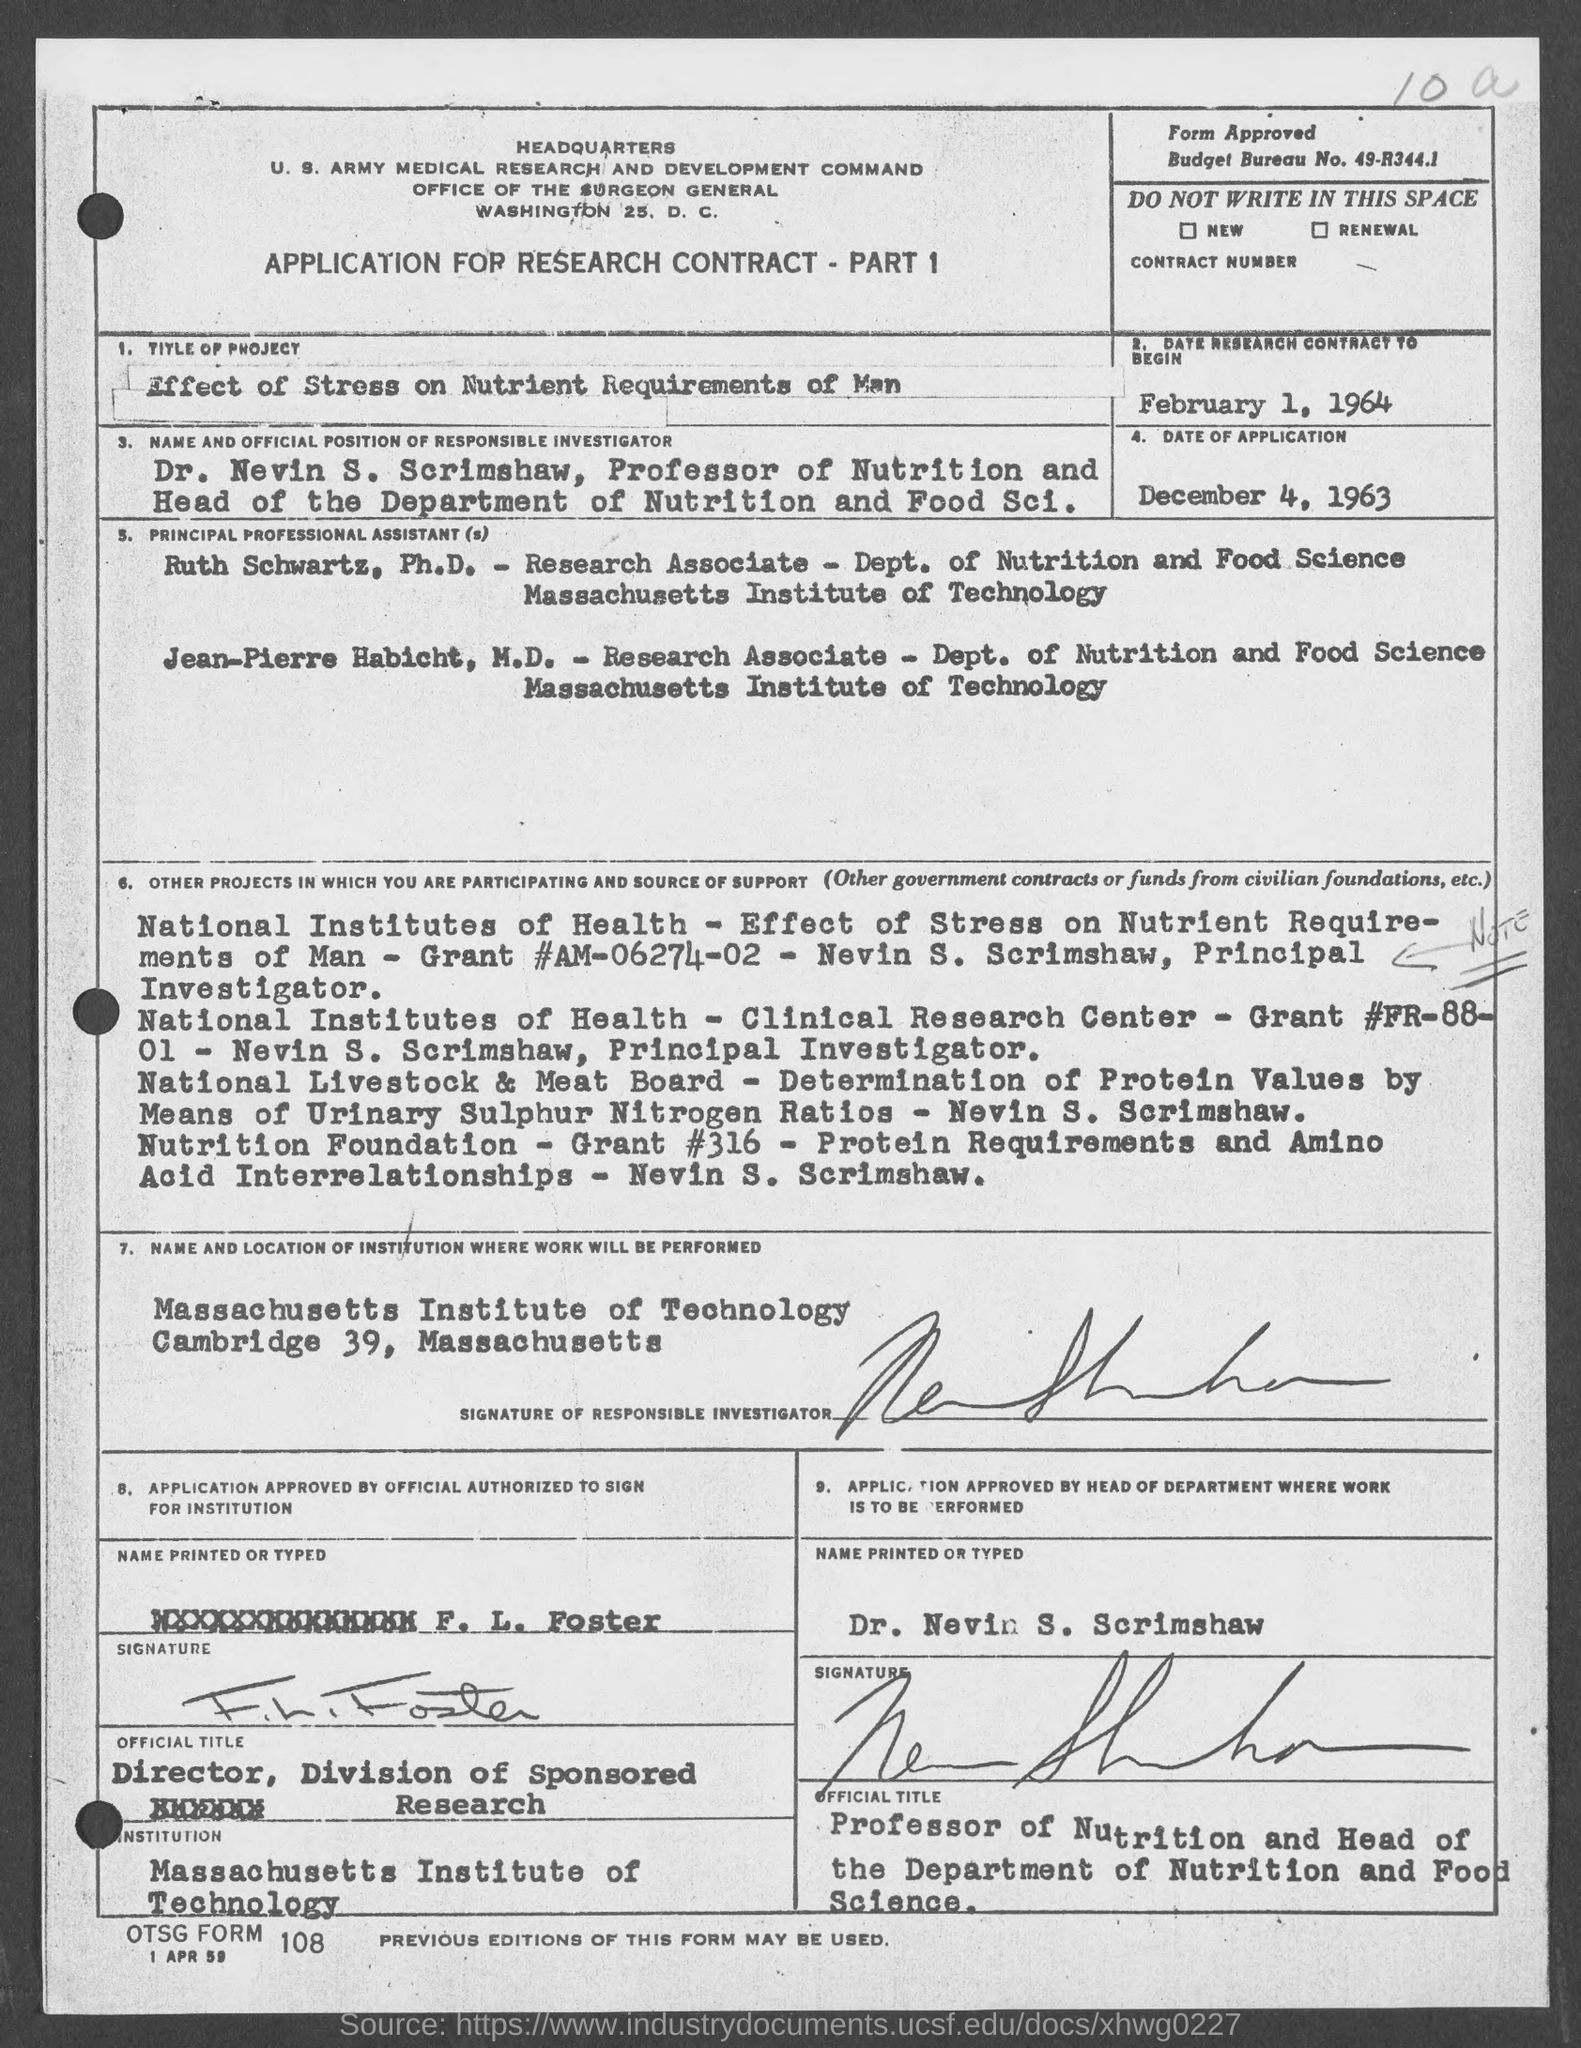Give some essential details in this illustration. The budget bureau number is 49-R344.1. The date on which the research contract is set to commence is February 1, 1964. The head of the department is Dr. Nevin S. Scrimshaw. On December 4, 1963, the date of application was. 